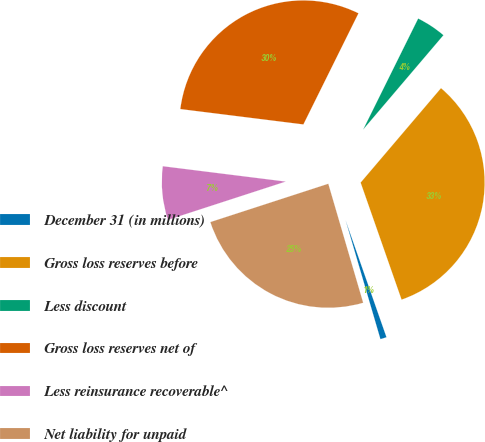Convert chart to OTSL. <chart><loc_0><loc_0><loc_500><loc_500><pie_chart><fcel>December 31 (in millions)<fcel>Gross loss reserves before<fcel>Less discount<fcel>Gross loss reserves net of<fcel>Less reinsurance recoverable^<fcel>Net liability for unpaid<nl><fcel>0.82%<fcel>33.43%<fcel>3.9%<fcel>30.35%<fcel>6.98%<fcel>24.54%<nl></chart> 